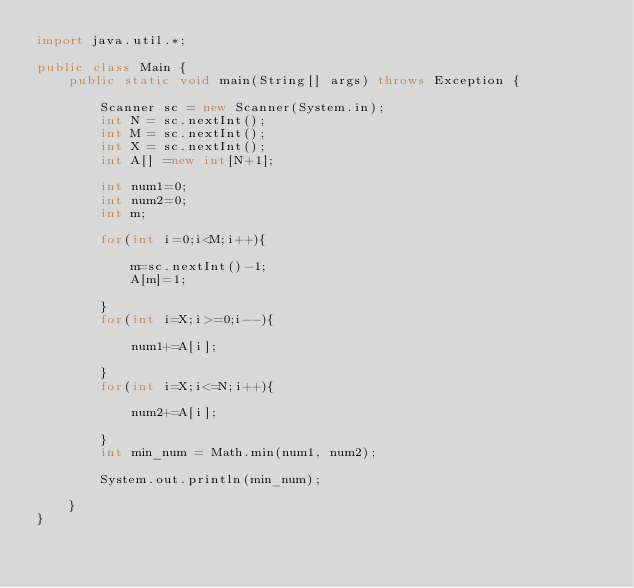Convert code to text. <code><loc_0><loc_0><loc_500><loc_500><_Java_>import java.util.*;

public class Main {
    public static void main(String[] args) throws Exception {
        
        Scanner sc = new Scanner(System.in);
        int N = sc.nextInt();
        int M = sc.nextInt();
        int X = sc.nextInt();
        int A[] =new int[N+1];
        
        int num1=0;
        int num2=0;
        int m;
        
        for(int i=0;i<M;i++){
            
            m=sc.nextInt()-1;
            A[m]=1;
            
        }
        for(int i=X;i>=0;i--){
            
            num1+=A[i];
            
        }
        for(int i=X;i<=N;i++){
            
            num2+=A[i];
            
        }
        int min_num = Math.min(num1, num2);
        
        System.out.println(min_num);
        
    }
}
</code> 